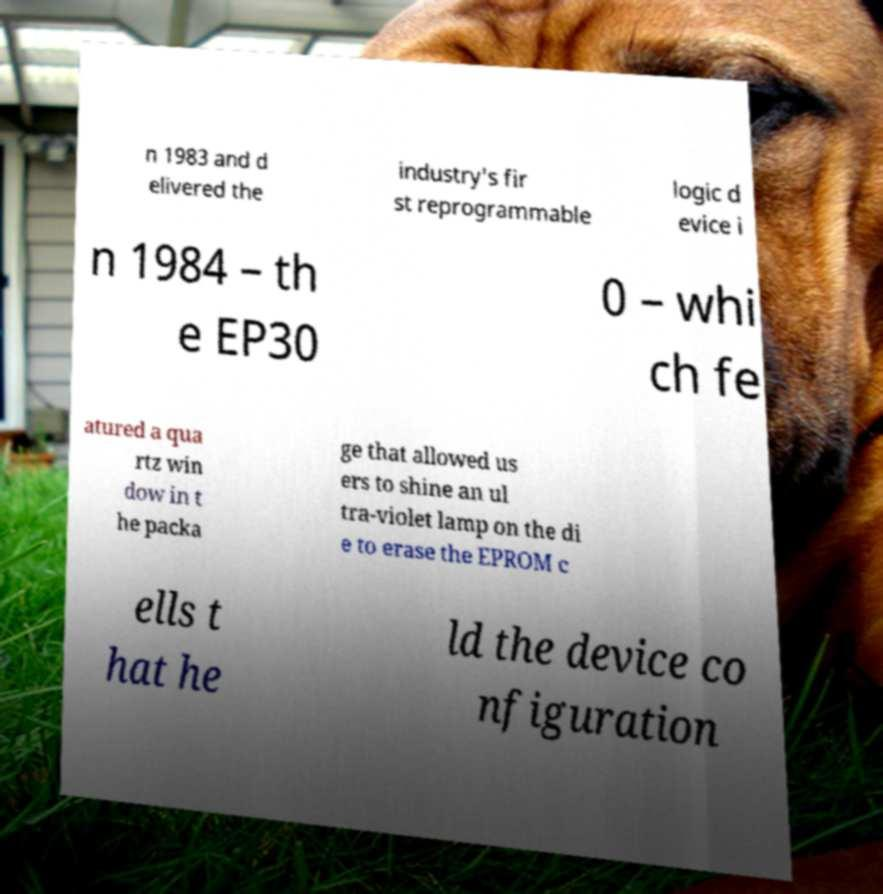There's text embedded in this image that I need extracted. Can you transcribe it verbatim? n 1983 and d elivered the industry's fir st reprogrammable logic d evice i n 1984 – th e EP30 0 – whi ch fe atured a qua rtz win dow in t he packa ge that allowed us ers to shine an ul tra-violet lamp on the di e to erase the EPROM c ells t hat he ld the device co nfiguration 